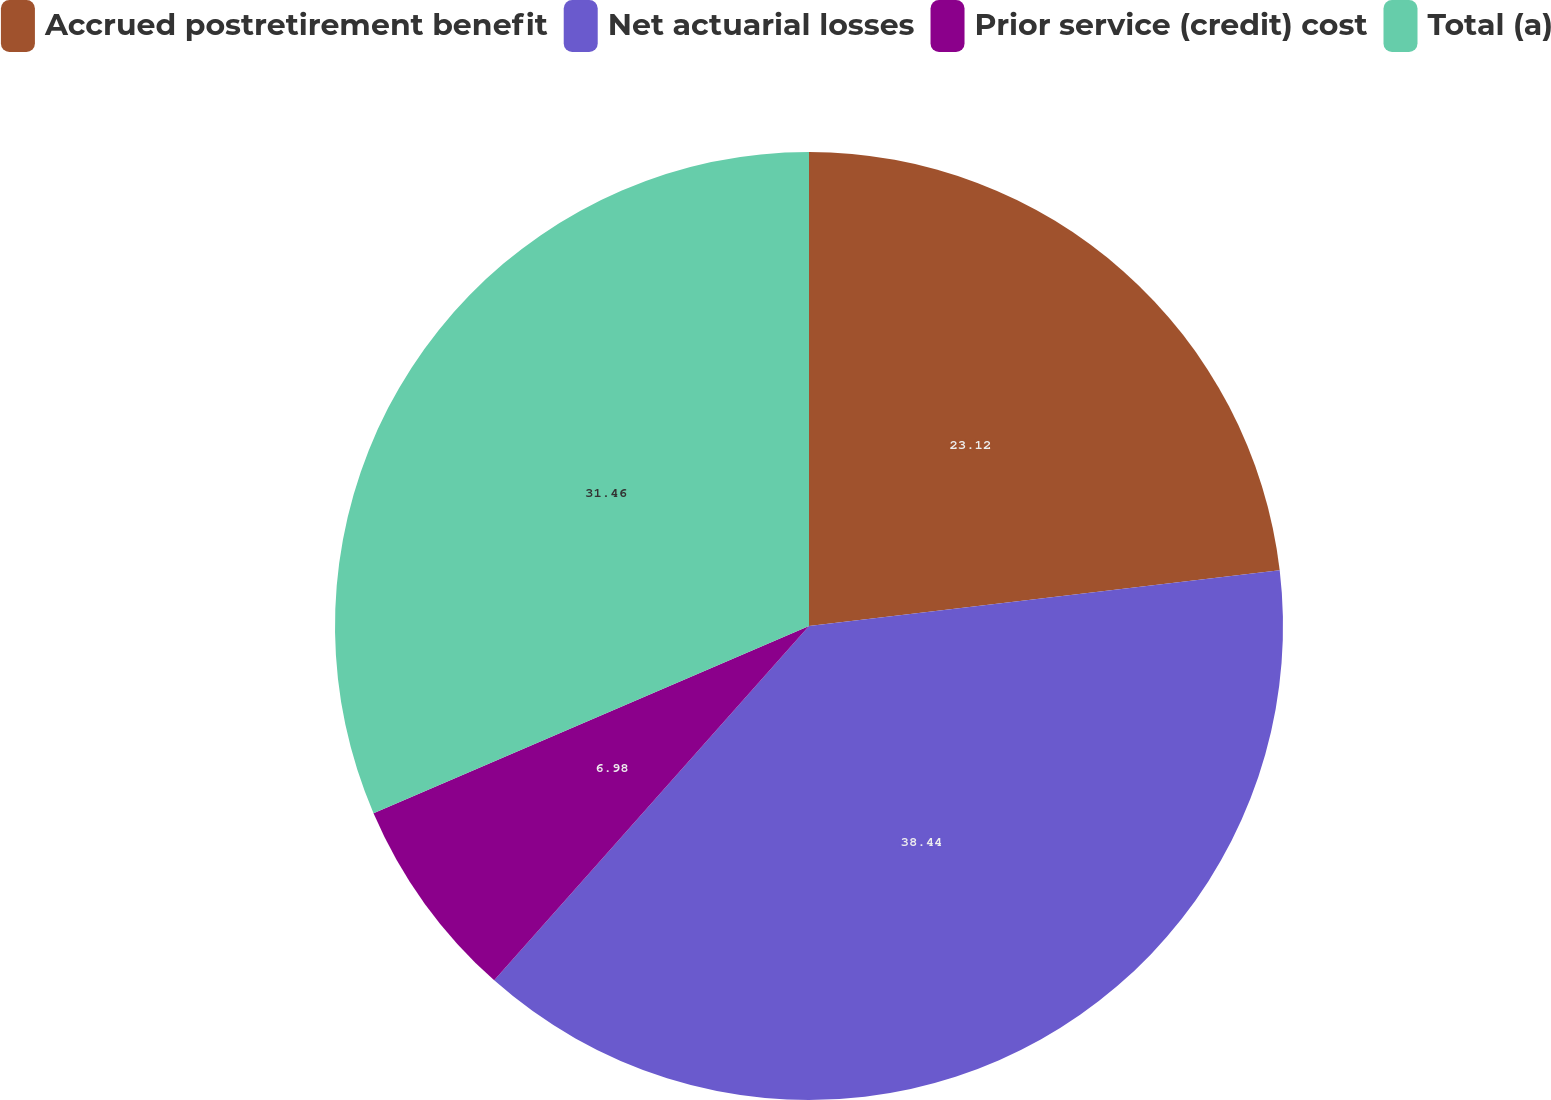Convert chart to OTSL. <chart><loc_0><loc_0><loc_500><loc_500><pie_chart><fcel>Accrued postretirement benefit<fcel>Net actuarial losses<fcel>Prior service (credit) cost<fcel>Total (a)<nl><fcel>23.12%<fcel>38.44%<fcel>6.98%<fcel>31.46%<nl></chart> 